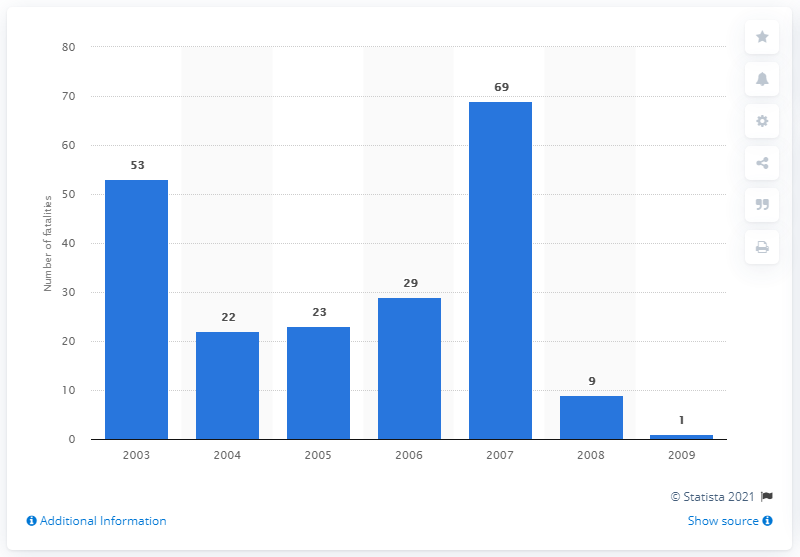Draw attention to some important aspects in this diagram. In 2007, 69 British soldiers lost their lives while serving in Iraq. 